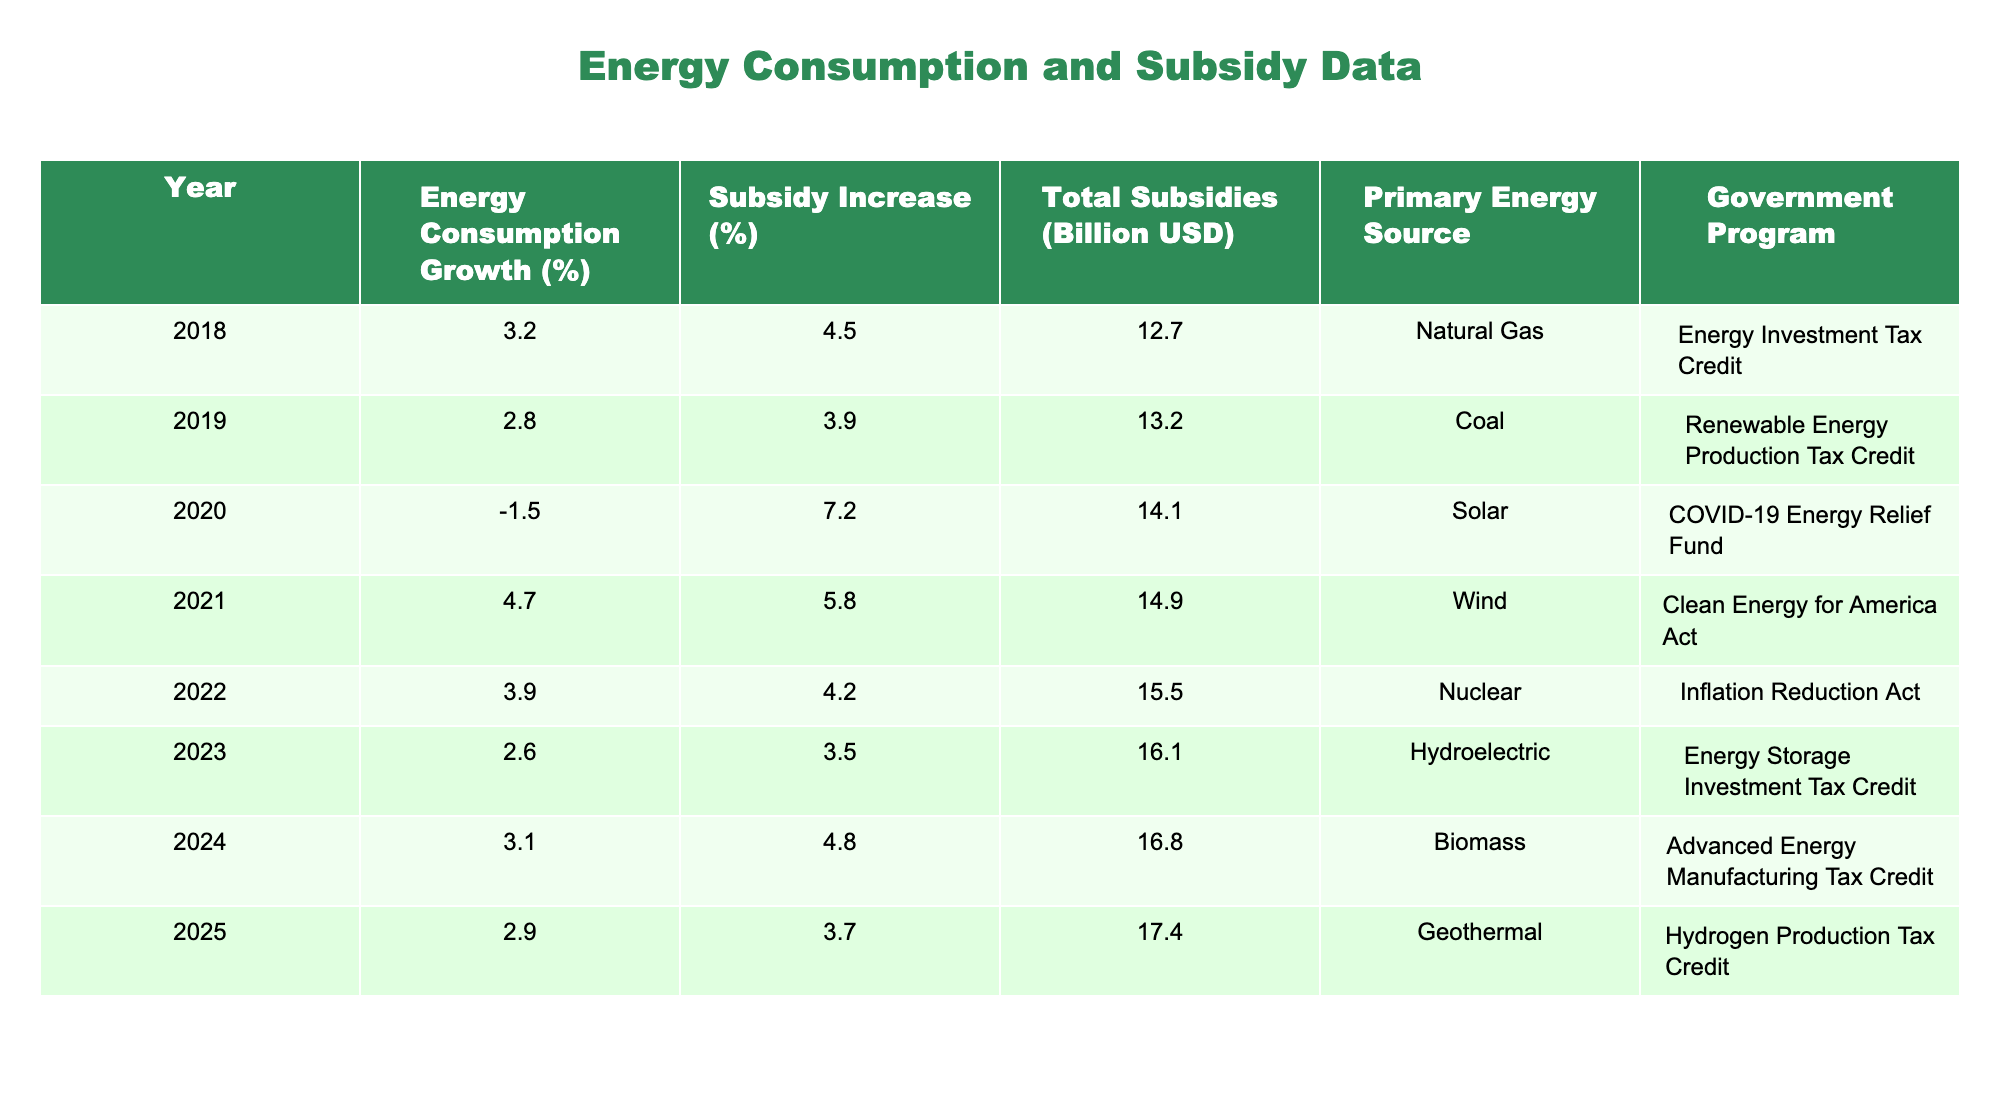What was the highest percentage of energy consumption growth over the years shown? By examining the "Energy Consumption Growth (%)" column, the value of 4.7% in the year 2021 is the highest.
Answer: 4.7% Which year had the lowest subsidy increase percentage? In the "Subsidy Increase (%)" column, 2.6% is the lowest percentage, which occurred in the year 2019.
Answer: 2.6% What is the total subsidy amount in 2022? The "Total Subsidies (Billion USD)" column indicates that in 2022, the total subsidy amount was 15.5 billion USD.
Answer: 15.5 billion USD Which year had both a decrease in energy consumption and the highest subsidy increase? The year 2020 had a negative growth in energy consumption at -1.5% but the highest subsidy increase at 7.2%.
Answer: 2020 Calculate the average total subsidies from 2018 to 2025. The total subsidies from 2018 to 2025 are 12.7, 13.2, 14.1, 14.9, 15.5, 16.1, 16.8, and 17.4 billion USD. Summing these gives 12.7 + 13.2 + 14.1 + 14.9 + 15.5 + 16.1 + 16.8 + 17.4 = 120.7 billion USD. Dividing by 8, the average is 120.7 / 8 = 15.0875 billion USD.
Answer: 15.1 billion USD Is there a consistent trend in subsidy increase percentages over the years? When reviewing the "Subsidy Increase (%)" column, the percentages seem to slightly fluctuate without a clear upward or downward trend. This suggests inconsistency in the subsidy increases.
Answer: No Which primary energy source corresponds to the year with the highest energy consumption growth? The year with the highest growth of 4.7% in energy consumption is 2021, which corresponds to the primary energy source Wind.
Answer: Wind What is the difference in total subsidies between 2023 and 2018? The total subsidies for 2023 are 16.1 billion USD and for 2018 are 12.7 billion USD. The difference is 16.1 - 12.7 = 3.4 billion USD.
Answer: 3.4 billion USD Which government program was associated with the largest total subsidy amount? In 2025, the total subsidy amount was 17.4 billion USD, which was associated with the Hydrogen Production Tax Credit program.
Answer: Hydrogen Production Tax Credit In how many years did the energy consumption growth exceed 3%? The years with energy consumption growth exceeding 3% are 2018, 2021, and 2022, totaling 3 years.
Answer: 3 years What can you infer about the relationship between energy consumption growth and subsidy increases from 2018 to 2025? Analyzing the data, it appears that years with higher energy consumption growth (like 4.7% in 2021) do not necessarily align with the highest subsidy increases, indicating that growth and subsidy are not directly correlated.
Answer: They are not directly correlated 